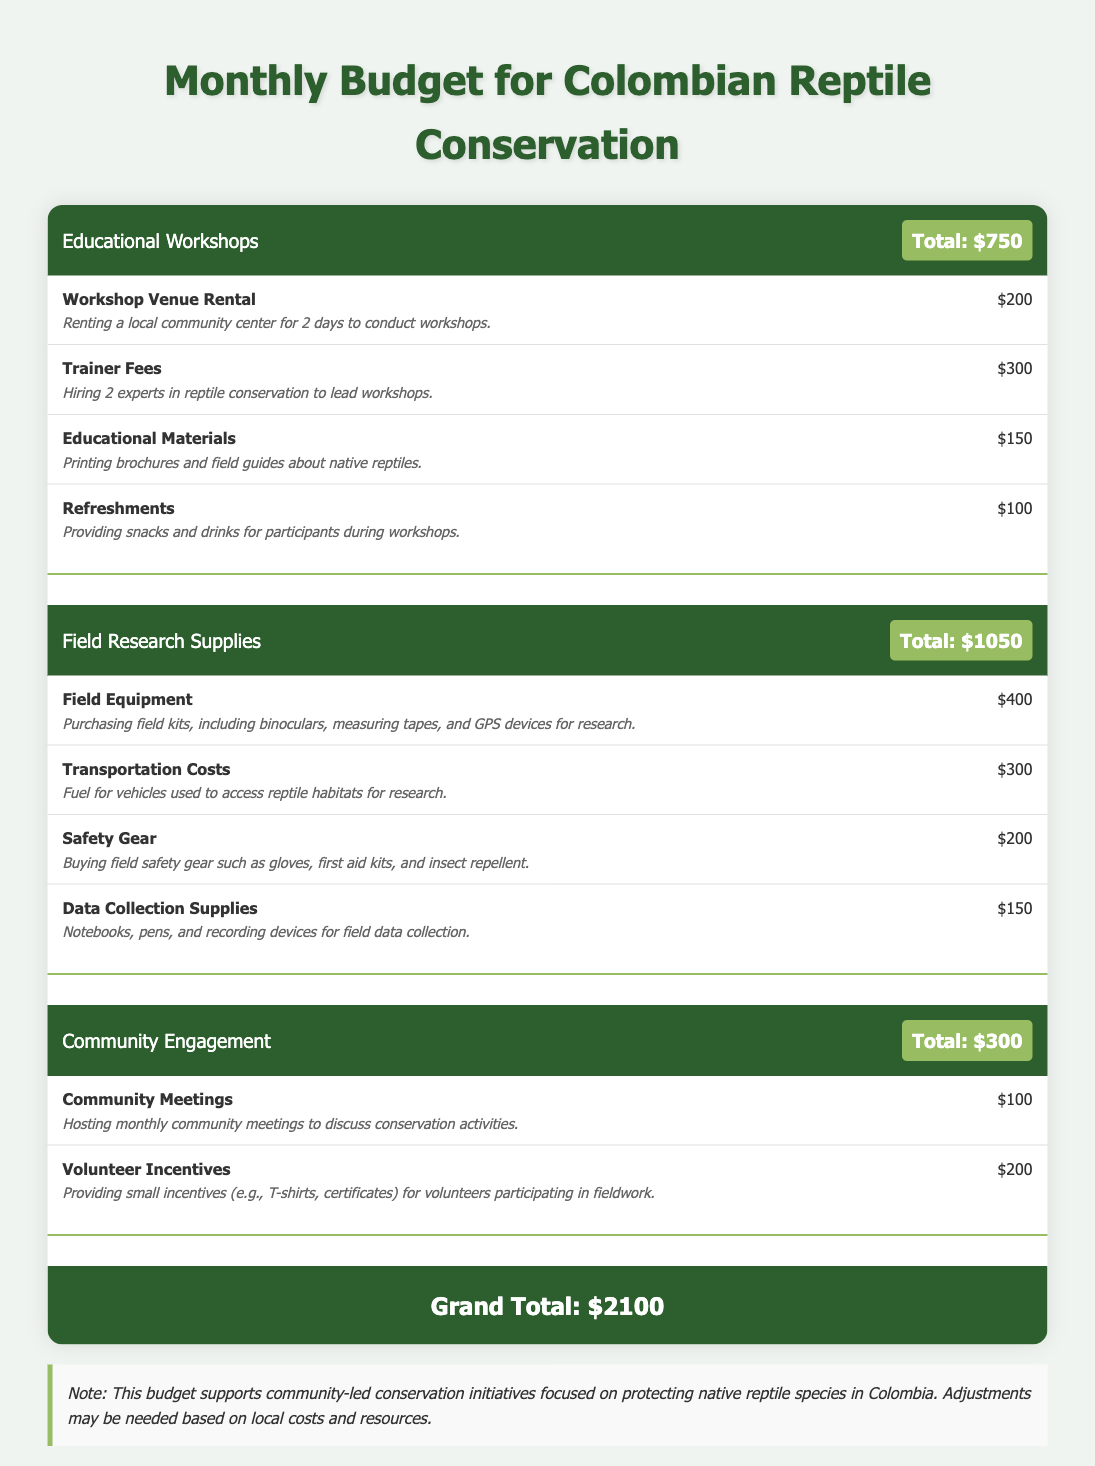What is the total budget for educational workshops? The total budget for educational workshops is indicated clearly in the document as $750.
Answer: $750 What item has the highest expense in field research supplies? The highest expense in field research supplies is field equipment, which costs $400.
Answer: Field Equipment How much is allocated for volunteer incentives? The budget indicates that $200 is allocated specifically for volunteer incentives.
Answer: $200 What is the grand total of the budget? The grand total of the budget is the sum of all categories, which totals $2100.
Answer: $2100 How many experts are hired for the workshops? The document mentions that 2 experts in reptile conservation are being hired to lead the workshops.
Answer: 2 experts What is the expense for transportation costs? The transportation costs are listed as $300 in the budget for the field research supplies category.
Answer: $300 What type of community engagement activity is included? One of the community engagement activities included is hosting monthly community meetings.
Answer: Community Meetings How much is allocated for safety gear in field research supplies? The budget specifies that $200 is allocated for buying safety gear.
Answer: $200 What is included in the educational materials expense? The educational materials expense includes printing brochures and field guides about native reptiles.
Answer: Printing brochures and field guides 